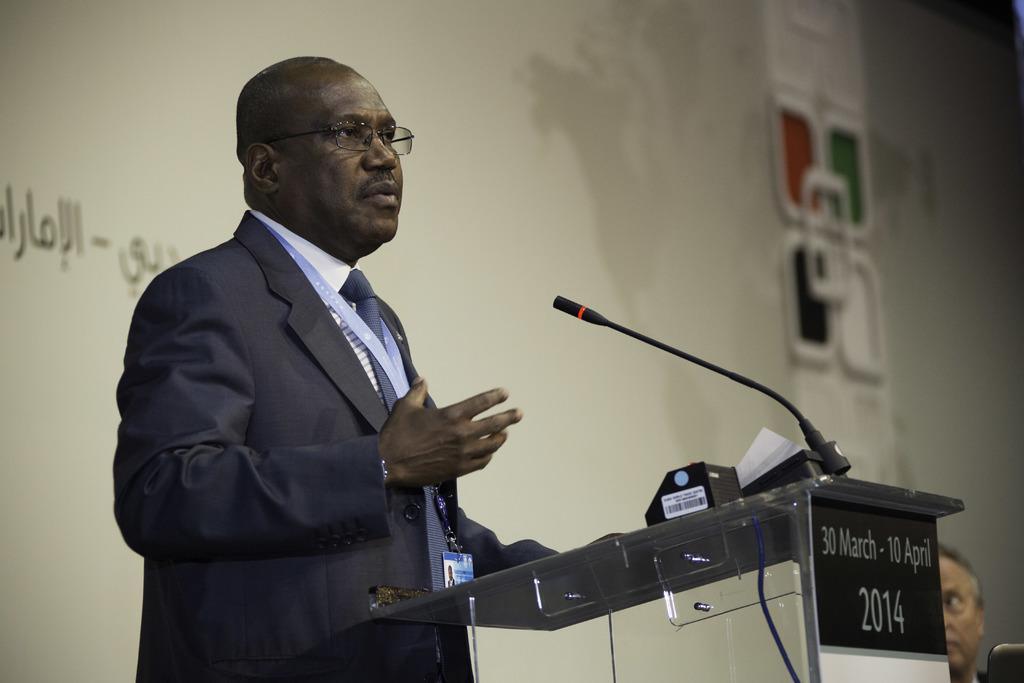Can you describe this image briefly? Here we can see a man standing in front of a mike and he wore spectacles. There is a podium. Here we can see a person. In the background we can see a screen. 